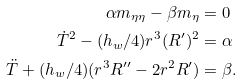<formula> <loc_0><loc_0><loc_500><loc_500>\alpha m _ { \eta \eta } - \beta m _ { \eta } & = 0 \\ \dot { T } ^ { 2 } - ( h _ { w } / 4 ) r ^ { 3 } ( R ^ { \prime } ) ^ { 2 } & = \alpha \\ \ddot { T } + ( h _ { w } / 4 ) ( r ^ { 3 } R ^ { \prime \prime } - 2 r ^ { 2 } R ^ { \prime } ) & = \beta .</formula> 